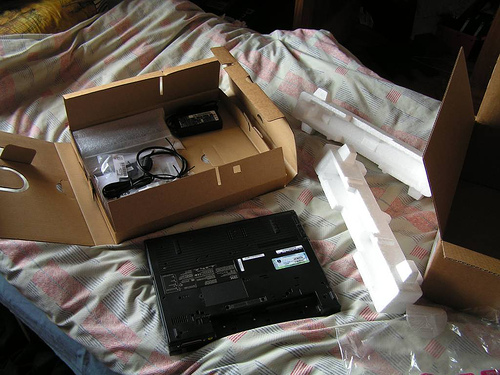<image>What is the price of this piece of electronic item? I don't know the exact price of this electronic item. It could range between a few hundred to six hundred dollars. What is the price of this piece of electronic item? I don't know the price of this piece of electronic item. It can be around $100, $500 or $200. 